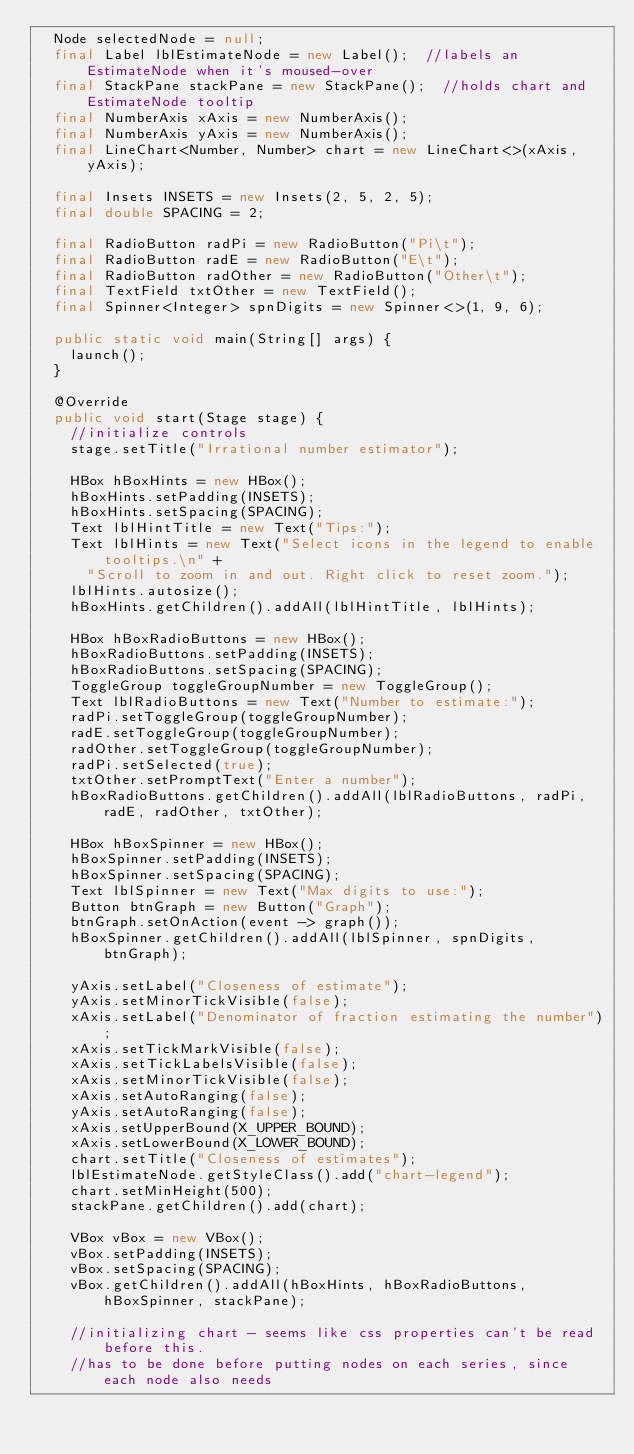<code> <loc_0><loc_0><loc_500><loc_500><_Java_>	Node selectedNode = null;
	final Label lblEstimateNode = new Label();	//labels an EstimateNode when it's moused-over
	final StackPane stackPane = new StackPane();	//holds chart and EstimateNode tooltip
	final NumberAxis xAxis = new NumberAxis();
	final NumberAxis yAxis = new NumberAxis();
	final LineChart<Number, Number> chart = new LineChart<>(xAxis, yAxis);

	final Insets INSETS = new Insets(2, 5, 2, 5);
	final double SPACING = 2;

	final RadioButton radPi = new RadioButton("Pi\t");
	final RadioButton radE = new RadioButton("E\t");
	final RadioButton radOther = new RadioButton("Other\t");
	final TextField txtOther = new TextField();
	final Spinner<Integer> spnDigits = new Spinner<>(1, 9, 6);

	public static void main(String[] args) {
		launch();
	}

	@Override
	public void start(Stage stage) {
		//initialize controls
		stage.setTitle("Irrational number estimator");

		HBox hBoxHints = new HBox();
		hBoxHints.setPadding(INSETS);
		hBoxHints.setSpacing(SPACING);
		Text lblHintTitle = new Text("Tips:");
		Text lblHints = new Text("Select icons in the legend to enable tooltips.\n" +
			"Scroll to zoom in and out. Right click to reset zoom.");
		lblHints.autosize();
		hBoxHints.getChildren().addAll(lblHintTitle, lblHints);

		HBox hBoxRadioButtons = new HBox();
		hBoxRadioButtons.setPadding(INSETS);
		hBoxRadioButtons.setSpacing(SPACING);
		ToggleGroup toggleGroupNumber = new ToggleGroup();
		Text lblRadioButtons = new Text("Number to estimate:");
		radPi.setToggleGroup(toggleGroupNumber);
		radE.setToggleGroup(toggleGroupNumber);
		radOther.setToggleGroup(toggleGroupNumber);
		radPi.setSelected(true);
		txtOther.setPromptText("Enter a number");
		hBoxRadioButtons.getChildren().addAll(lblRadioButtons, radPi, radE, radOther, txtOther);

		HBox hBoxSpinner = new HBox();
		hBoxSpinner.setPadding(INSETS);
		hBoxSpinner.setSpacing(SPACING);
		Text lblSpinner = new Text("Max digits to use:");
		Button btnGraph = new Button("Graph");
		btnGraph.setOnAction(event -> graph());
		hBoxSpinner.getChildren().addAll(lblSpinner, spnDigits, btnGraph);

		yAxis.setLabel("Closeness of estimate");
		yAxis.setMinorTickVisible(false);
		xAxis.setLabel("Denominator of fraction estimating the number");
		xAxis.setTickMarkVisible(false);
		xAxis.setTickLabelsVisible(false);
		xAxis.setMinorTickVisible(false);
		xAxis.setAutoRanging(false);
		yAxis.setAutoRanging(false);
		xAxis.setUpperBound(X_UPPER_BOUND);
		xAxis.setLowerBound(X_LOWER_BOUND);
		chart.setTitle("Closeness of estimates");
		lblEstimateNode.getStyleClass().add("chart-legend");
		chart.setMinHeight(500);
		stackPane.getChildren().add(chart);

		VBox vBox = new VBox();
		vBox.setPadding(INSETS);
		vBox.setSpacing(SPACING);
		vBox.getChildren().addAll(hBoxHints, hBoxRadioButtons, hBoxSpinner, stackPane);

		//initializing chart - seems like css properties can't be read before this.
		//has to be done before putting nodes on each series, since each node also needs</code> 